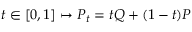<formula> <loc_0><loc_0><loc_500><loc_500>t \in [ 0 , 1 ] \mapsto P _ { t } = t Q + ( 1 - t ) P</formula> 